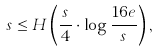<formula> <loc_0><loc_0><loc_500><loc_500>s \leq H \left ( \frac { s } { 4 } \cdot \log \frac { 1 6 e } { s } \right ) ,</formula> 